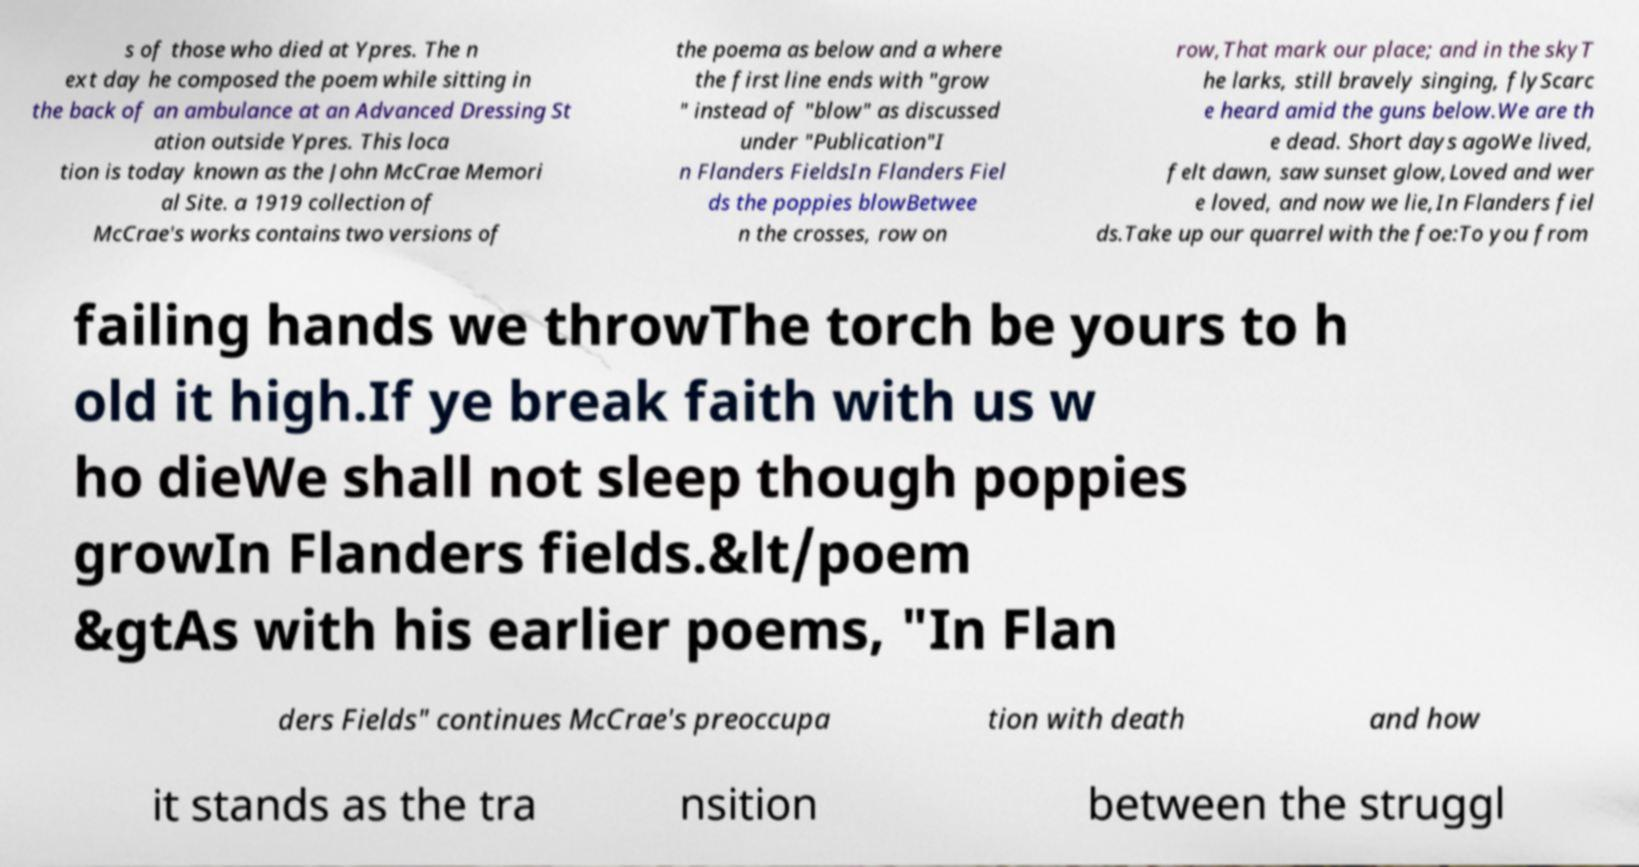Could you extract and type out the text from this image? s of those who died at Ypres. The n ext day he composed the poem while sitting in the back of an ambulance at an Advanced Dressing St ation outside Ypres. This loca tion is today known as the John McCrae Memori al Site. a 1919 collection of McCrae's works contains two versions of the poema as below and a where the first line ends with "grow " instead of "blow" as discussed under "Publication"I n Flanders FieldsIn Flanders Fiel ds the poppies blowBetwee n the crosses, row on row,That mark our place; and in the skyT he larks, still bravely singing, flyScarc e heard amid the guns below.We are th e dead. Short days agoWe lived, felt dawn, saw sunset glow,Loved and wer e loved, and now we lie,In Flanders fiel ds.Take up our quarrel with the foe:To you from failing hands we throwThe torch be yours to h old it high.If ye break faith with us w ho dieWe shall not sleep though poppies growIn Flanders fields.&lt/poem &gtAs with his earlier poems, "In Flan ders Fields" continues McCrae's preoccupa tion with death and how it stands as the tra nsition between the struggl 